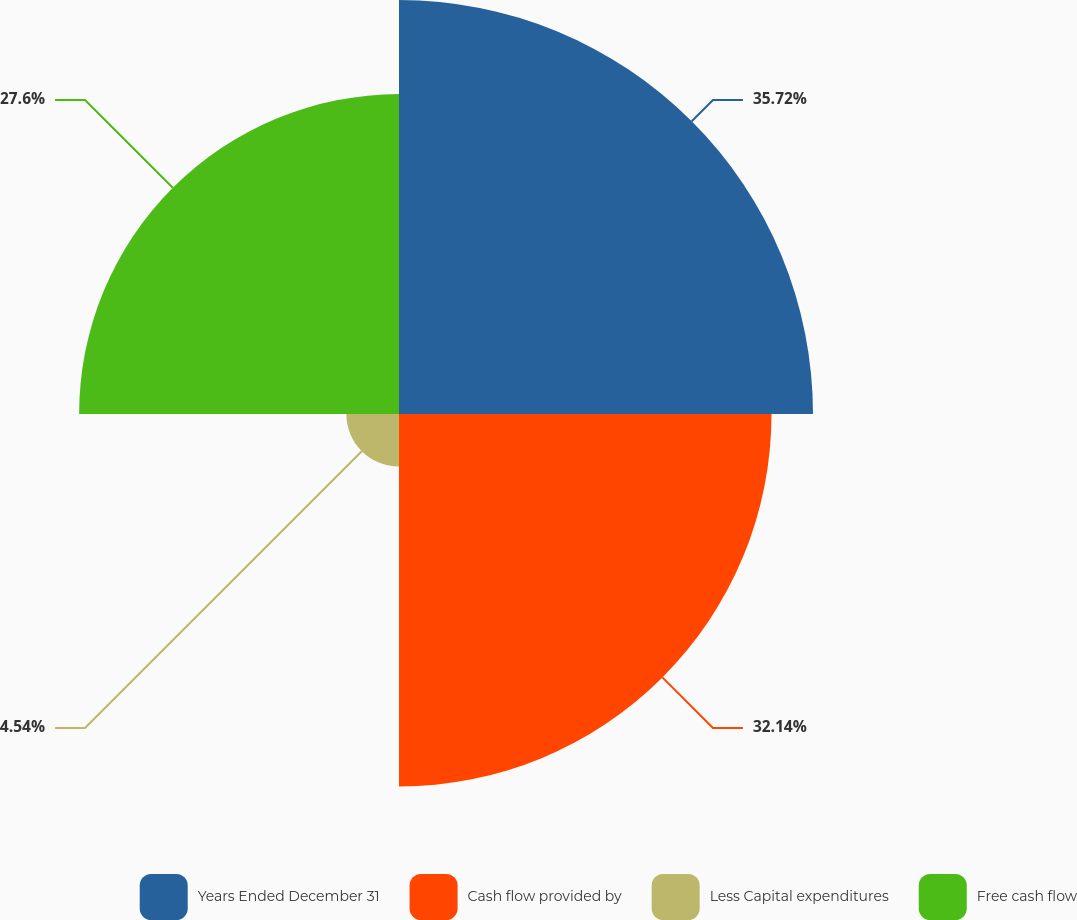Convert chart. <chart><loc_0><loc_0><loc_500><loc_500><pie_chart><fcel>Years Ended December 31<fcel>Cash flow provided by<fcel>Less Capital expenditures<fcel>Free cash flow<nl><fcel>35.72%<fcel>32.14%<fcel>4.54%<fcel>27.6%<nl></chart> 